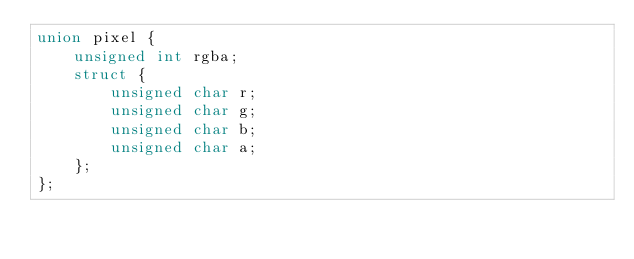<code> <loc_0><loc_0><loc_500><loc_500><_C_>union pixel {
    unsigned int rgba;
    struct {
        unsigned char r;
        unsigned char g;
        unsigned char b;
        unsigned char a;
    };
};
</code> 